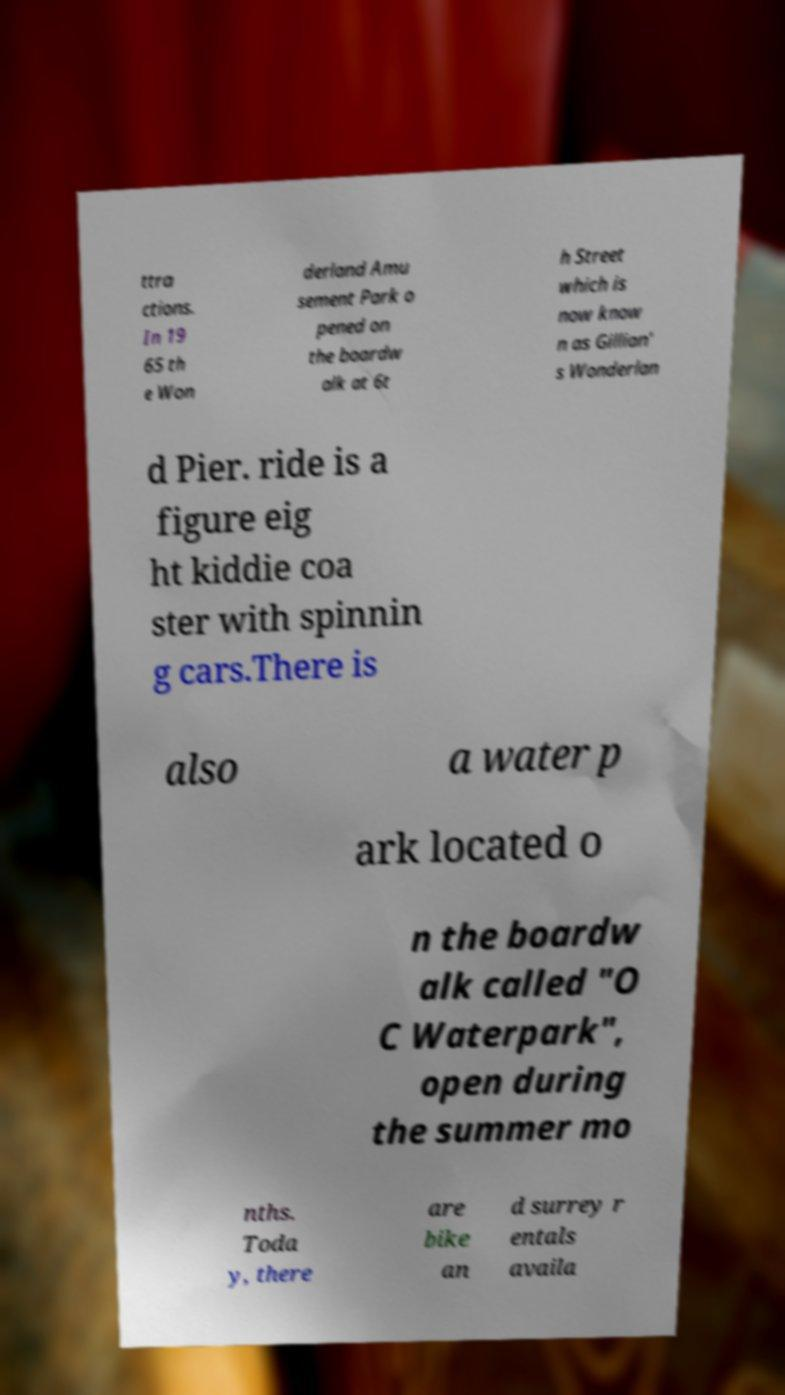Please identify and transcribe the text found in this image. ttra ctions. In 19 65 th e Won derland Amu sement Park o pened on the boardw alk at 6t h Street which is now know n as Gillian' s Wonderlan d Pier. ride is a figure eig ht kiddie coa ster with spinnin g cars.There is also a water p ark located o n the boardw alk called "O C Waterpark", open during the summer mo nths. Toda y, there are bike an d surrey r entals availa 